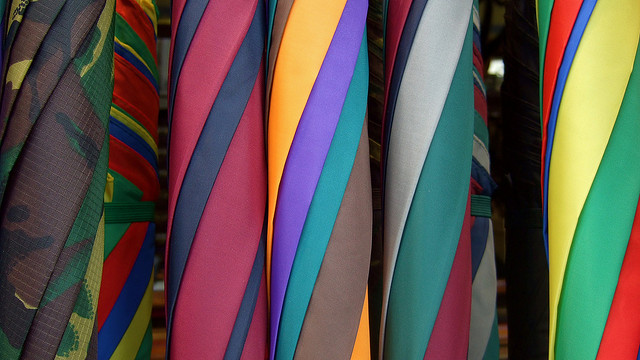<image>What color is predominant? It's ambiguous what the predominant color is. It could be yellow, blue, or green. What color is predominant? I don't know the predominant color. It can be seen yellow, blue, green or teal. 